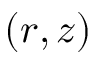Convert formula to latex. <formula><loc_0><loc_0><loc_500><loc_500>( r , z )</formula> 